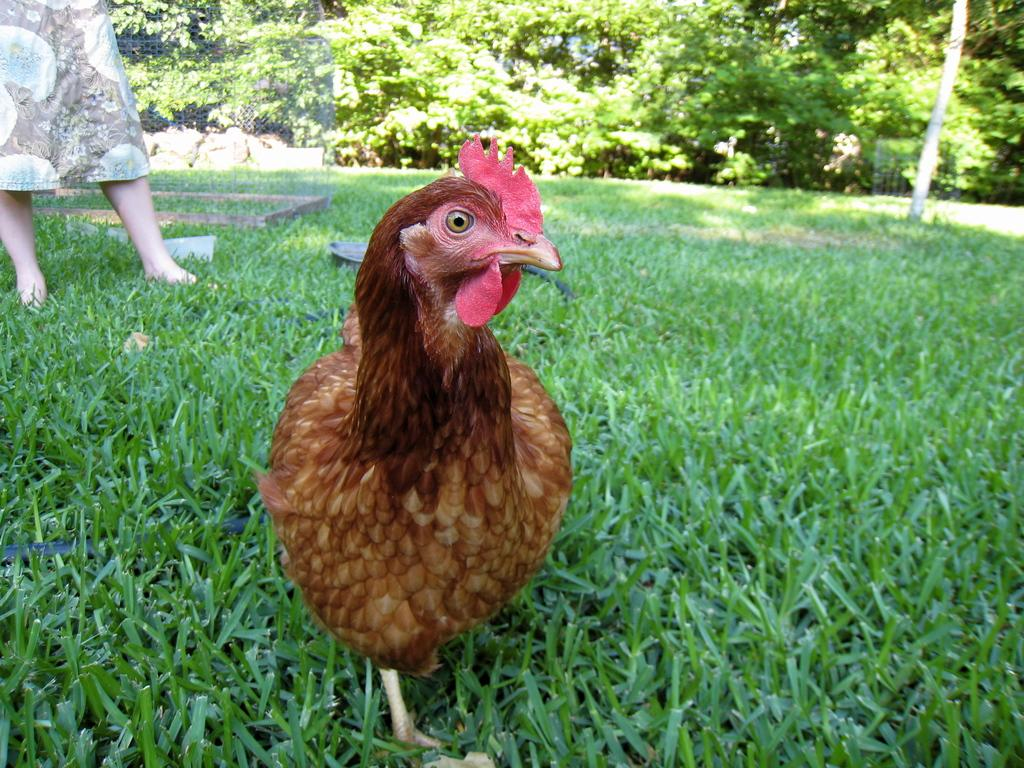What animal is the main subject of the image? There is a hen in the image. How is the hen positioned in relation to other elements in the image? The hen is in front of other elements in the image. What type of vegetation can be seen in the image? There is grass visible in the image. Can you describe the background of the image? There is a woman and plants in the background of the image. What type of theory is the hen discussing with the woman in the background? There is no indication in the image that the hen is discussing any theory with the woman, as animals do not engage in theoretical discussions. 